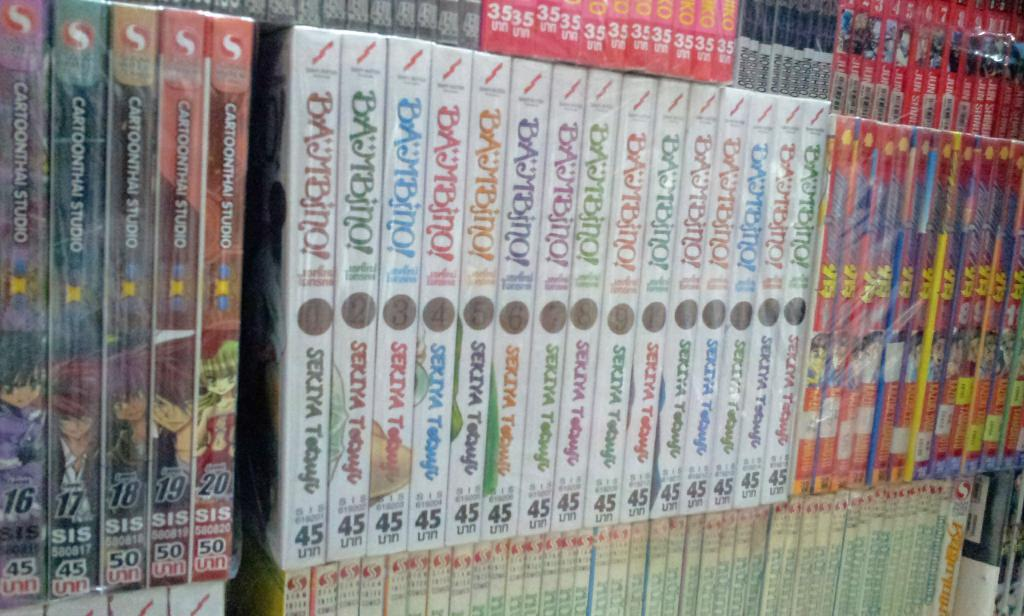<image>
Present a compact description of the photo's key features. the word studio is on one of the many books 